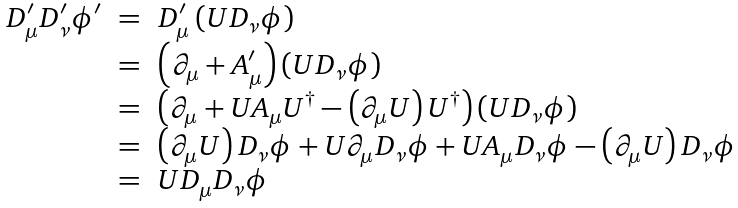Convert formula to latex. <formula><loc_0><loc_0><loc_500><loc_500>\begin{array} { r c l } D ^ { \prime } _ { \mu } D ^ { \prime } _ { \nu } \phi ^ { \prime } & = & D ^ { \prime } _ { \mu } \left ( U D _ { \nu } \phi \right ) \\ & = & \left ( \partial _ { \mu } + A ^ { \prime } _ { \mu } \right ) \left ( U D _ { \nu } \phi \right ) \\ & = & \left ( \partial _ { \mu } + U A _ { \mu } U ^ { \dagger } - \left ( \partial _ { \mu } U \right ) U ^ { \dagger } \right ) \left ( U D _ { \nu } \phi \right ) \\ & = & \left ( \partial _ { \mu } U \right ) D _ { \nu } \phi + U \partial _ { \mu } D _ { \nu } \phi + U A _ { \mu } D _ { \nu } \phi - \left ( \partial _ { \mu } U \right ) D _ { \nu } \phi \\ & = & U D _ { \mu } D _ { \nu } \phi \end{array}</formula> 